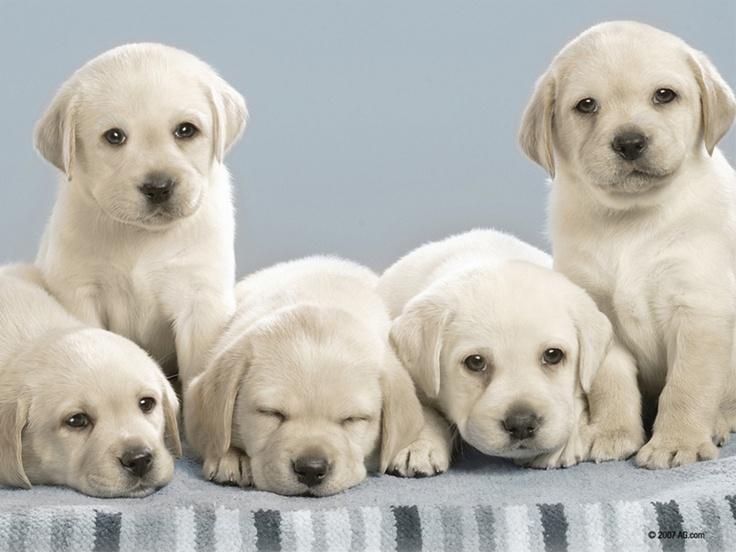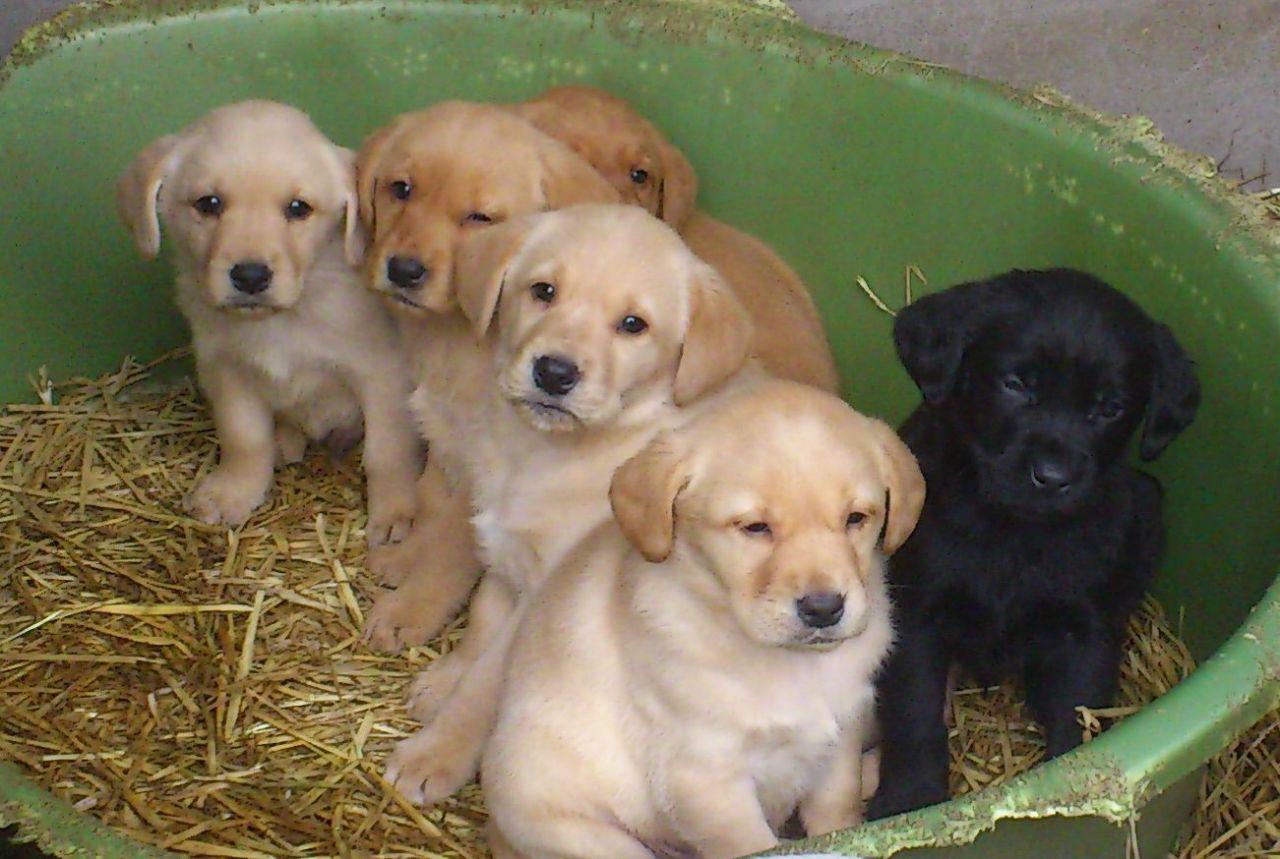The first image is the image on the left, the second image is the image on the right. Evaluate the accuracy of this statement regarding the images: "There are exactly five dogs in the image on the left.". Is it true? Answer yes or no. Yes. The first image is the image on the left, the second image is the image on the right. Considering the images on both sides, is "There is one black dog" valid? Answer yes or no. Yes. 